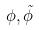Convert formula to latex. <formula><loc_0><loc_0><loc_500><loc_500>\phi , \tilde { \phi }</formula> 